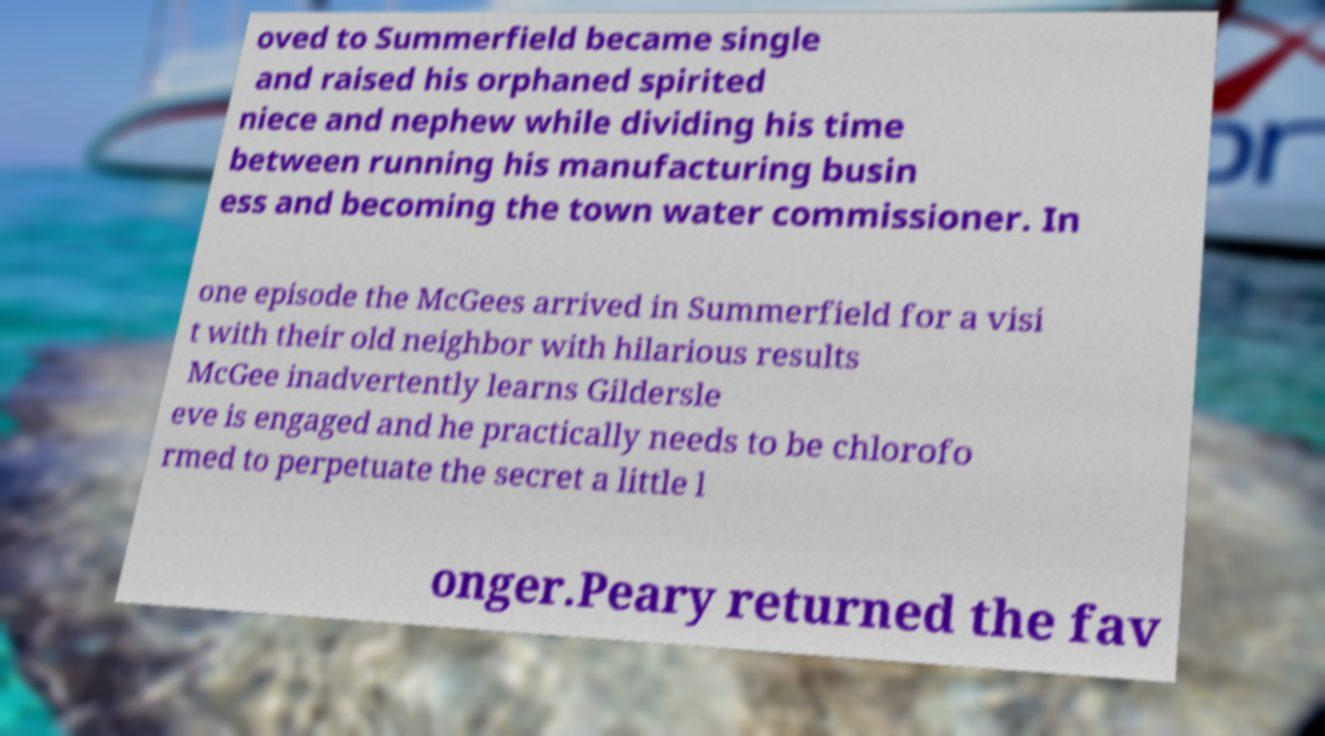Can you accurately transcribe the text from the provided image for me? oved to Summerfield became single and raised his orphaned spirited niece and nephew while dividing his time between running his manufacturing busin ess and becoming the town water commissioner. In one episode the McGees arrived in Summerfield for a visi t with their old neighbor with hilarious results McGee inadvertently learns Gildersle eve is engaged and he practically needs to be chlorofo rmed to perpetuate the secret a little l onger.Peary returned the fav 